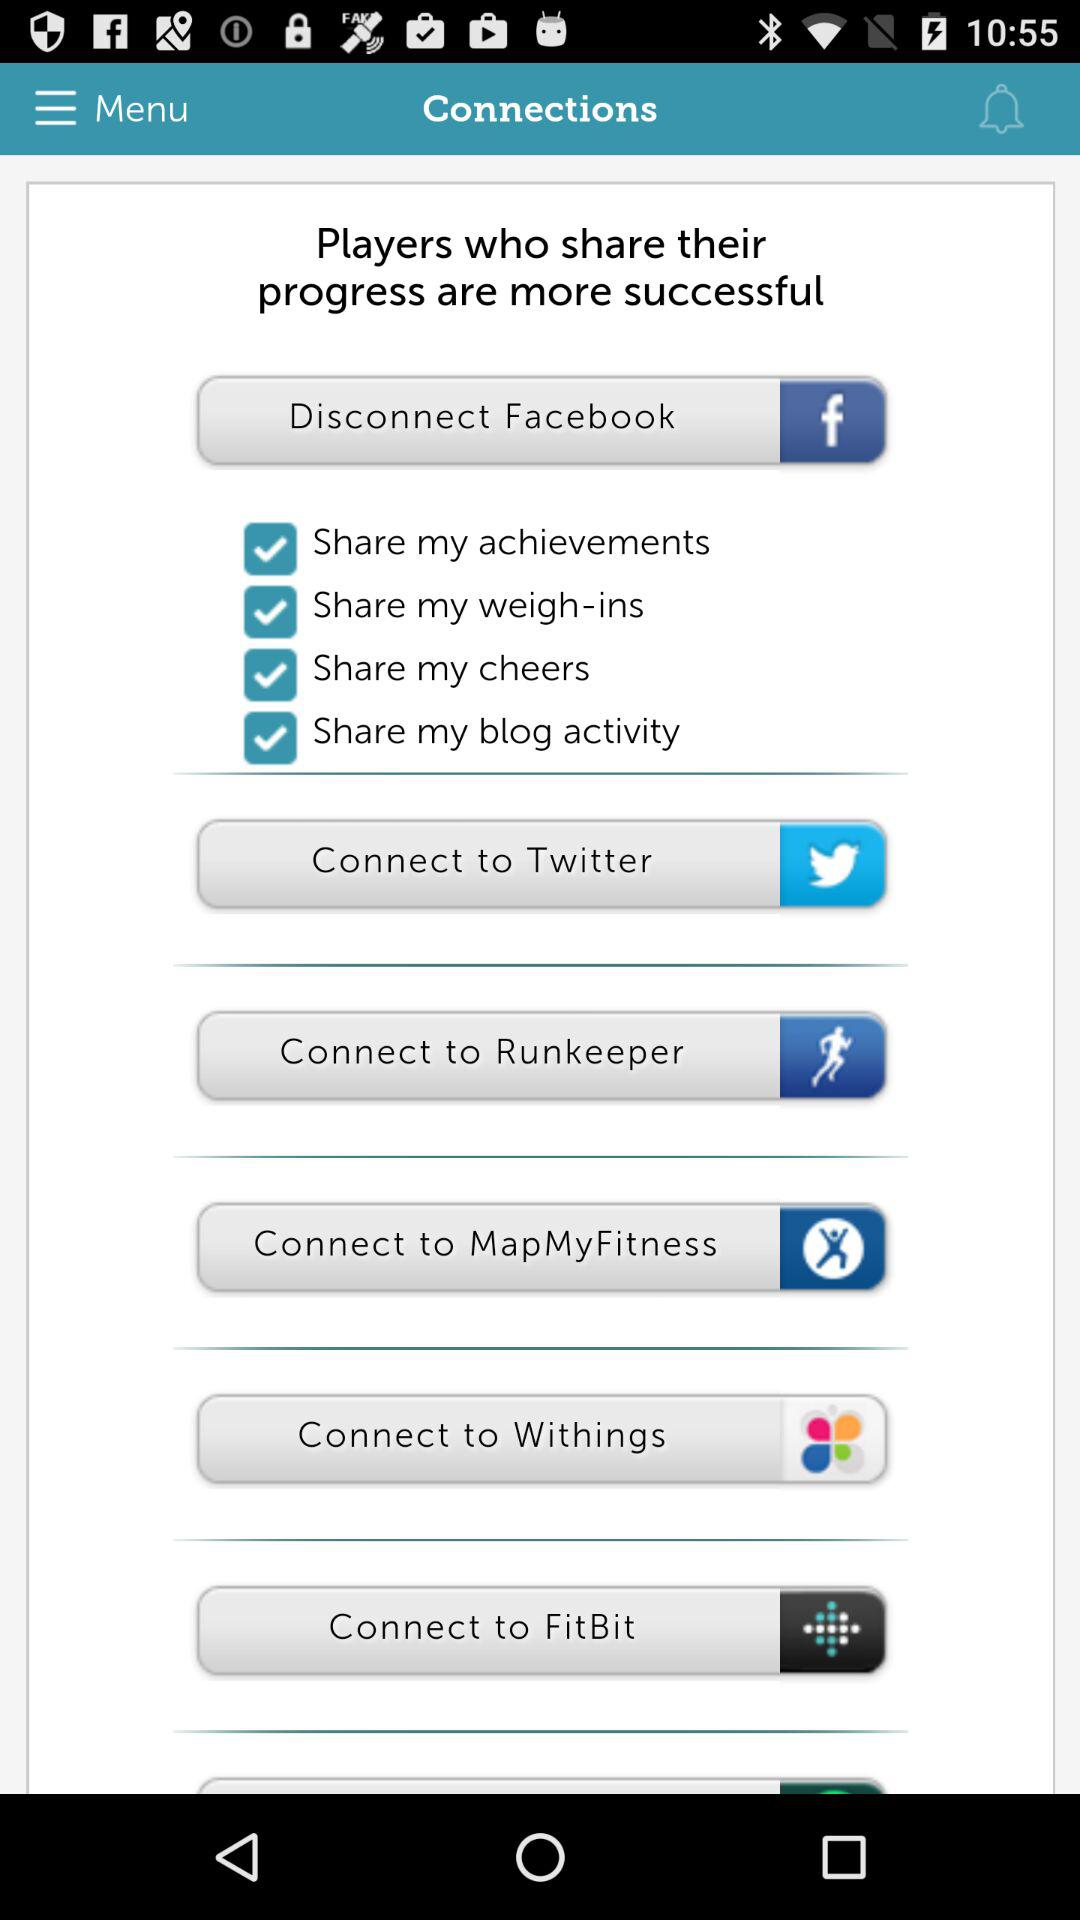From which application can the user disconnect? The user can disconnect from "Facebook". 